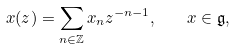<formula> <loc_0><loc_0><loc_500><loc_500>x ( z ) = \sum _ { n \in \mathbb { Z } } x _ { n } z ^ { - n - 1 } , \quad x \in { \mathfrak g } ,</formula> 